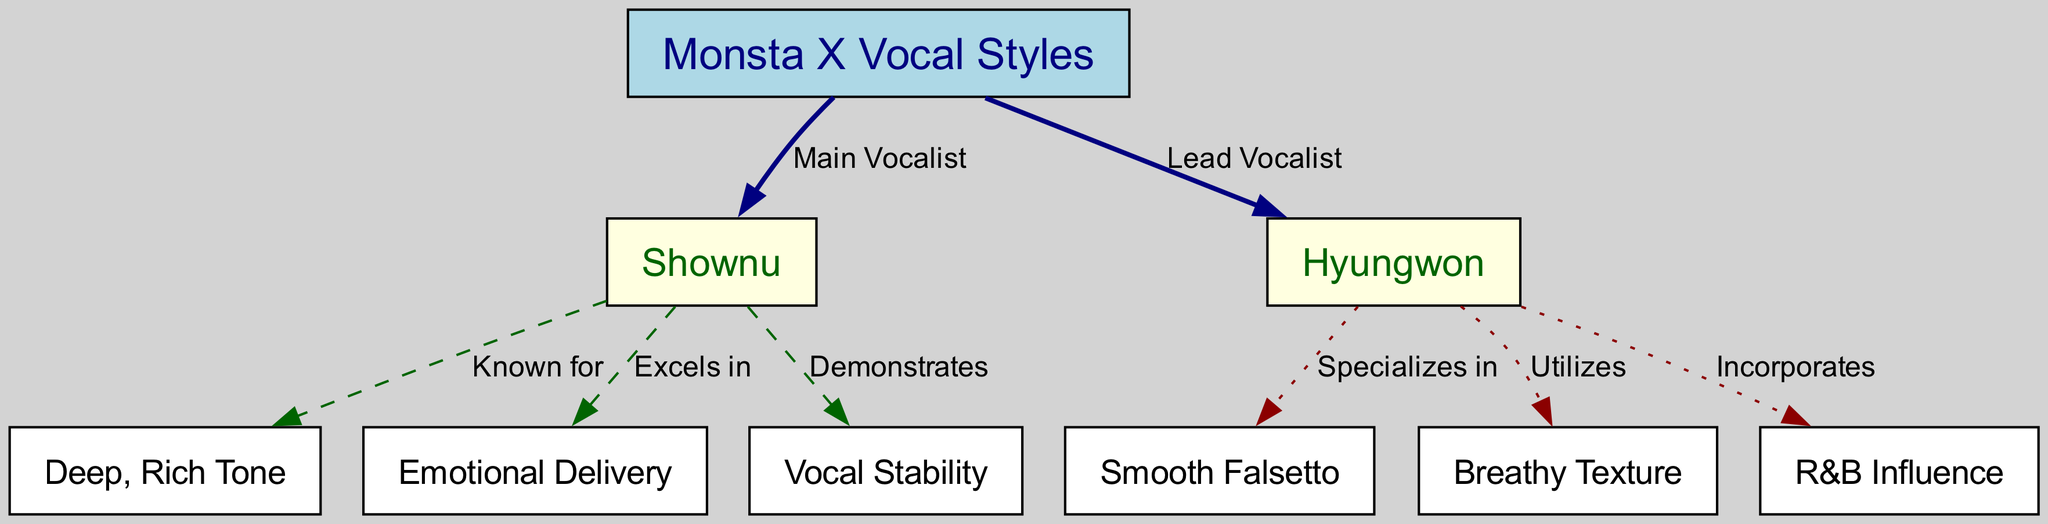What is the main role of Shownu in Monsta X? According to the diagram, Shownu is labeled as the "Main Vocalist" of Monsta X, indicating his primary role within the group.
Answer: Main Vocalist What vocal technique is Hyungwon known for? The diagram indicates that Hyungwon "Specializes in" a "Smooth Falsetto," which directly answers the question about his vocal technique.
Answer: Smooth Falsetto How many nodes are there in the diagram? Counting the nodes listed in the diagram, there are a total of 8 nodes present, which includes Monsta X and its members' unique vocal characteristics.
Answer: 8 Which vocalist is associated with "Deep, Rich Tone"? The diagram shows that "Deep, Rich Tone" is associated with Shownu as it states that he is "Known for" this characteristic, linking him directly to it.
Answer: Shownu What kind of texture does Hyungwon utilize in his singing? According to the information in the diagram, Hyungwon "Utilizes" a "Breathy Texture" in his vocal style, which provides the answer to this question.
Answer: Breathy Texture Which member demonstrates "Vocal Stability"? The diagram states that Shownu "Demonstrates" "Vocal Stability," indicating that this characteristic is attributed to him.
Answer: Shownu What influence does Hyungwon incorporate in his vocal style? The diagram states that Hyungwon "Incorporates" an "R&B Influence," which clearly answers the question regarding his musical influence.
Answer: R&B Influence How are the edges visually distinguished in the diagram? The edges connecting the nodes are differentiated by colors and styles, such as navy for Monsta X connections, dashed for Shownu, and dotted for Hyungwon, which indicates their relationships visually in the diagram.
Answer: Colors and styles What is the relationship between Shownu and Emotional Delivery? The diagram indicates that Shownu "Excels in" "Emotional Delivery," establishing a direct connection between the two concepts.
Answer: Excels in 